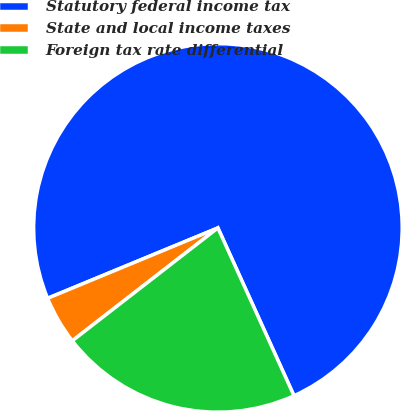Convert chart to OTSL. <chart><loc_0><loc_0><loc_500><loc_500><pie_chart><fcel>Statutory federal income tax<fcel>State and local income taxes<fcel>Foreign tax rate differential<nl><fcel>74.47%<fcel>4.26%<fcel>21.28%<nl></chart> 